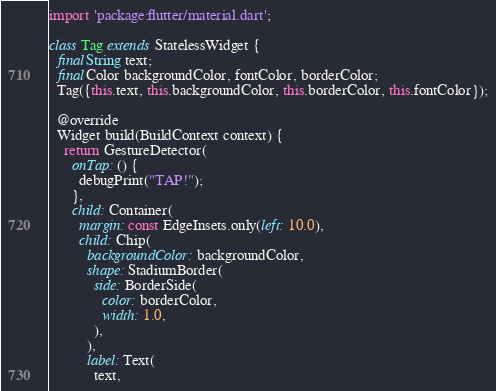<code> <loc_0><loc_0><loc_500><loc_500><_Dart_>import 'package:flutter/material.dart';

class Tag extends StatelessWidget {
  final String text;
  final Color backgroundColor, fontColor, borderColor;
  Tag({this.text, this.backgroundColor, this.borderColor, this.fontColor});

  @override
  Widget build(BuildContext context) {
    return GestureDetector(
      onTap: () {
        debugPrint("TAP!");
      },
      child: Container(
        margin: const EdgeInsets.only(left: 10.0),
        child: Chip(
          backgroundColor: backgroundColor,
          shape: StadiumBorder(
            side: BorderSide(
              color: borderColor,
              width: 1.0,
            ),
          ),
          label: Text(
            text,</code> 